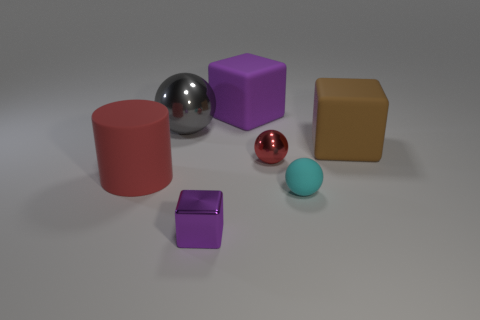Subtract all yellow cylinders. How many purple cubes are left? 2 Subtract all red spheres. How many spheres are left? 2 Add 1 small red things. How many objects exist? 8 Subtract all cubes. How many objects are left? 4 Add 2 large red matte things. How many large red matte things are left? 3 Add 1 cyan shiny objects. How many cyan shiny objects exist? 1 Subtract 0 yellow spheres. How many objects are left? 7 Subtract all big purple cubes. Subtract all big matte things. How many objects are left? 3 